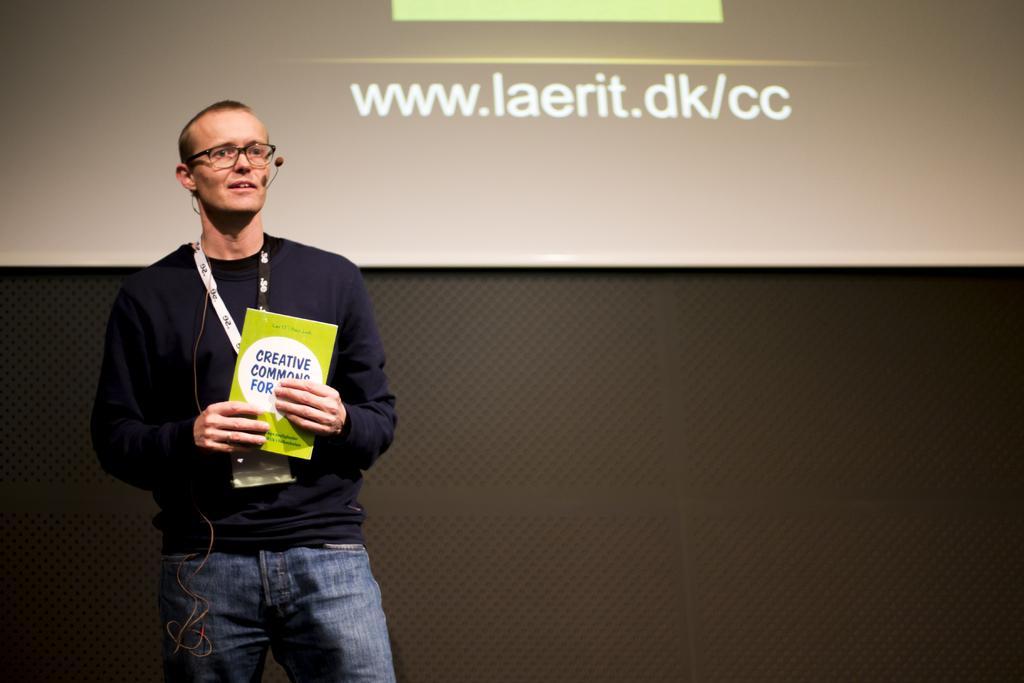Can you describe this image briefly? There is a man standing and holding a book and wore tag and microphone, behind him we can see screen and wall. 